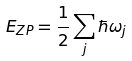Convert formula to latex. <formula><loc_0><loc_0><loc_500><loc_500>E _ { Z P } = \frac { 1 } { 2 } \sum _ { j } \hbar { \omega } _ { j }</formula> 